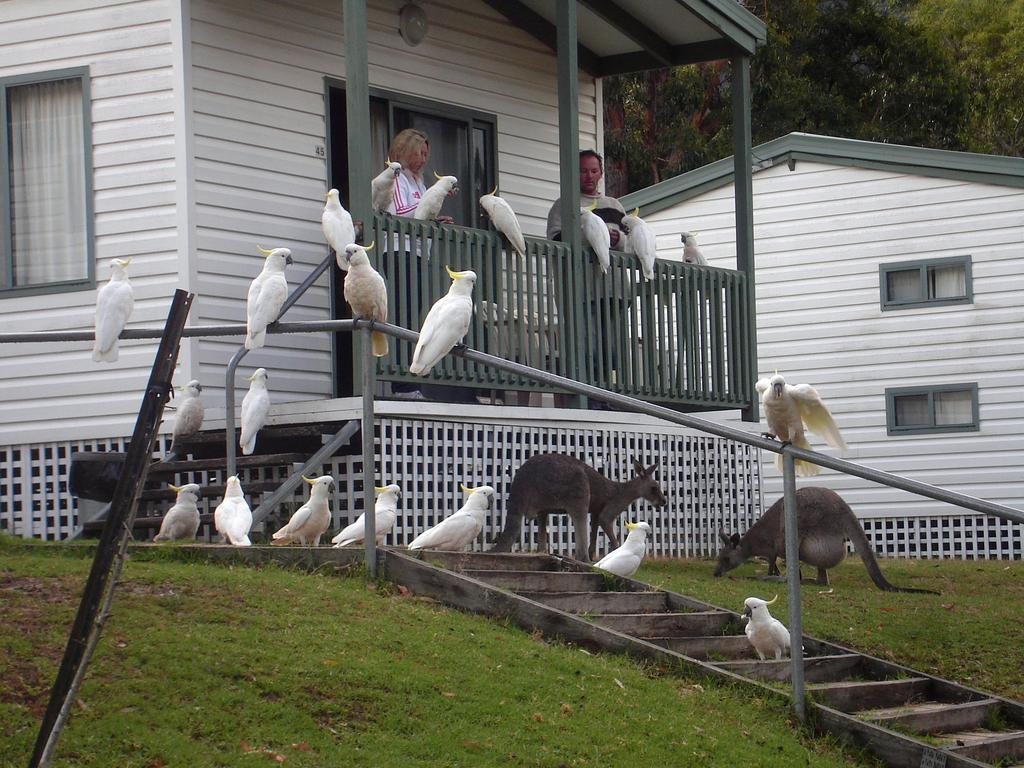What type of structure is present in the image? There is a house in the image. What features can be observed on the house? The house has windows and a fence. Who or what can be seen in the image? There are people and animals in the image. What is the setting of the image? There is grass visible in the image, and trees are in the background. What architectural element is present in the image? There are wooden stairs in the image. What is inside the house? The image shows curtains inside the house. What type of clam can be seen reacting to the hen in the image? There are no clams or hens present in the image. 